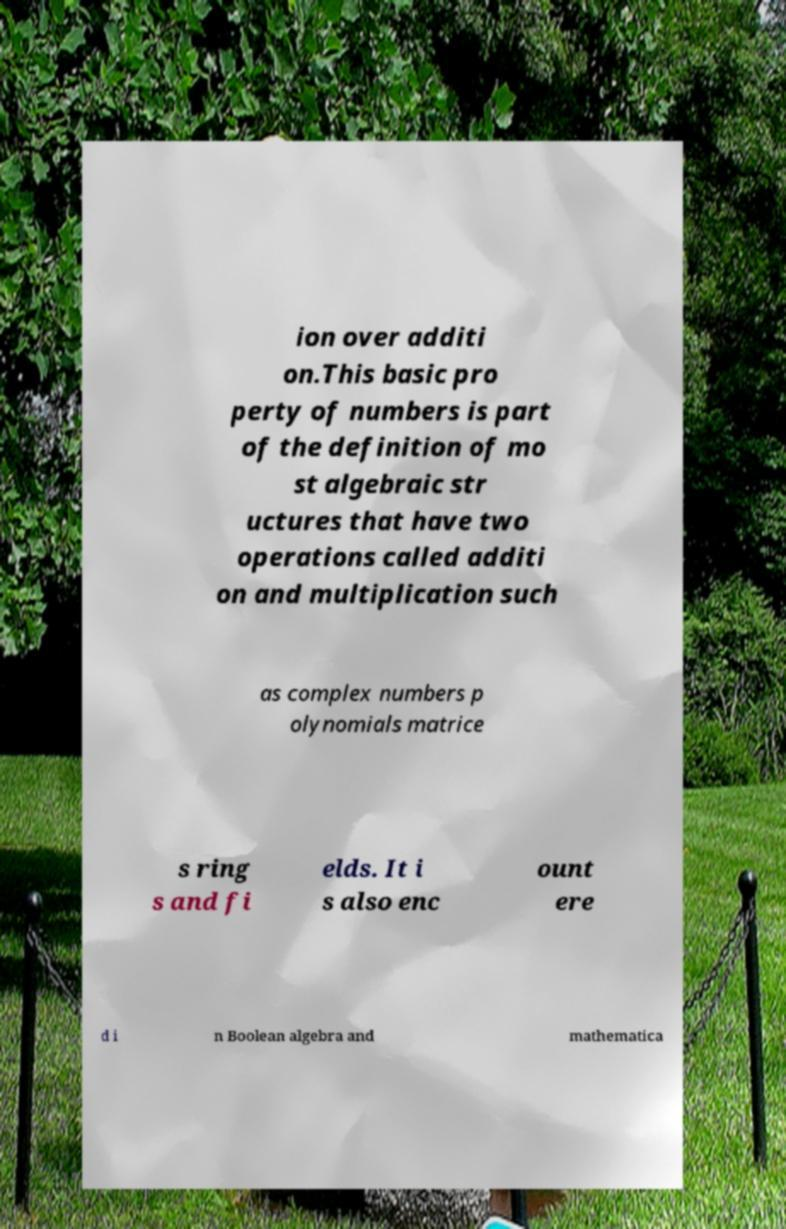Please identify and transcribe the text found in this image. ion over additi on.This basic pro perty of numbers is part of the definition of mo st algebraic str uctures that have two operations called additi on and multiplication such as complex numbers p olynomials matrice s ring s and fi elds. It i s also enc ount ere d i n Boolean algebra and mathematica 